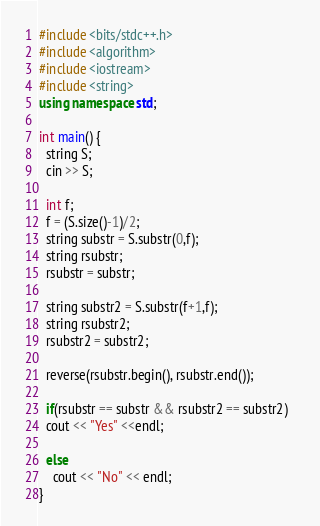<code> <loc_0><loc_0><loc_500><loc_500><_C++_>#include <bits/stdc++.h>
#include <algorithm>
#include <iostream>
#include <string>
using namespace std;
 
int main() {
  string S;
  cin >> S;
  
  int f;
  f = (S.size()-1)/2;
  string substr = S.substr(0,f);
  string rsubstr;
  rsubstr = substr;
  
  string substr2 = S.substr(f+1,f);
  string rsubstr2;
  rsubstr2 = substr2;
  
  reverse(rsubstr.begin(), rsubstr.end());
  
  if(rsubstr == substr && rsubstr2 == substr2)  
  cout << "Yes" <<endl;
  
  else
    cout << "No" << endl;
}</code> 